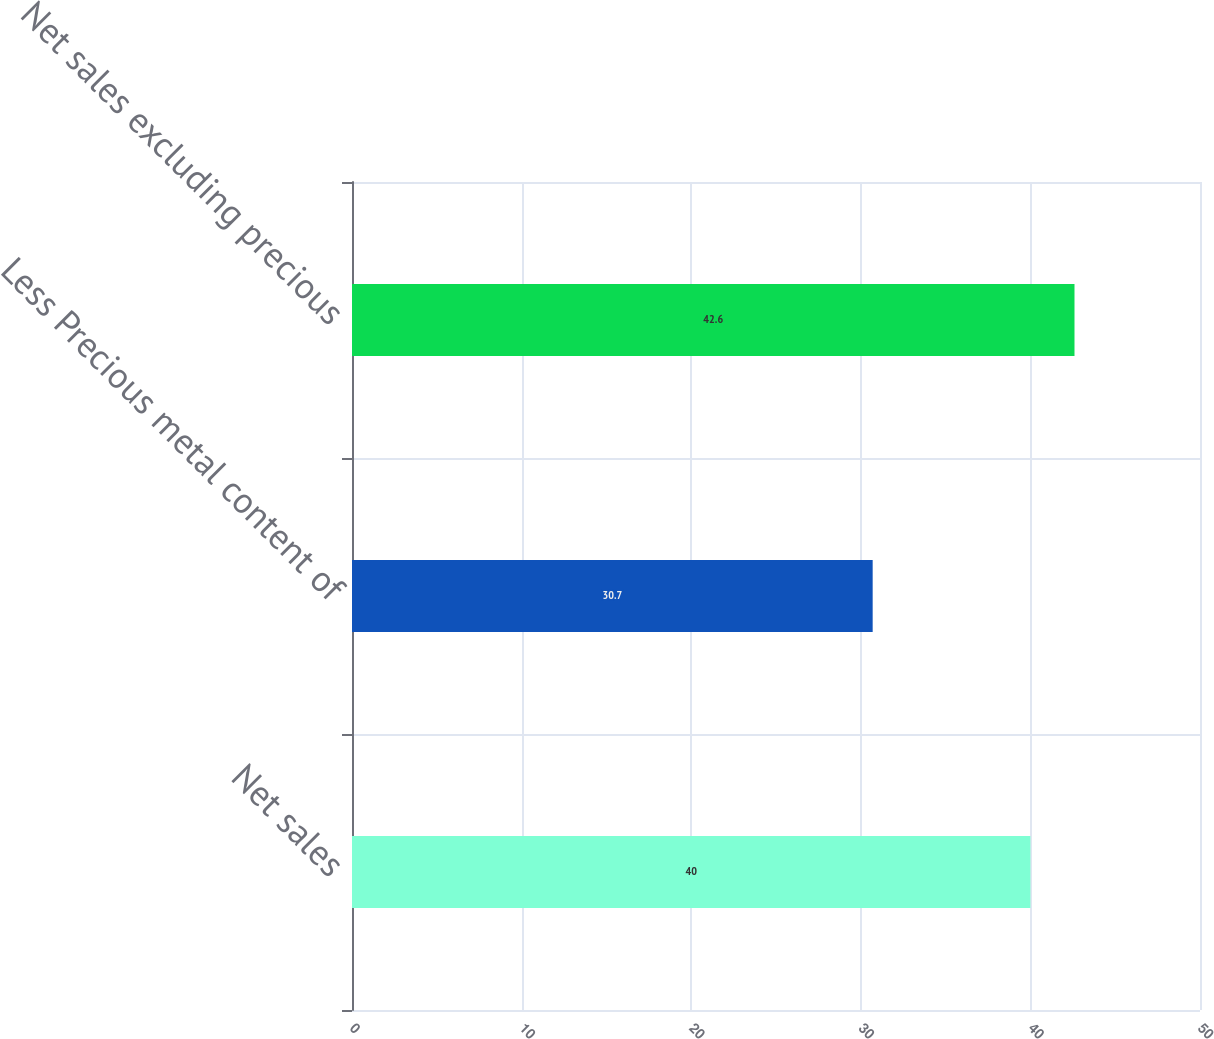Convert chart to OTSL. <chart><loc_0><loc_0><loc_500><loc_500><bar_chart><fcel>Net sales<fcel>Less Precious metal content of<fcel>Net sales excluding precious<nl><fcel>40<fcel>30.7<fcel>42.6<nl></chart> 